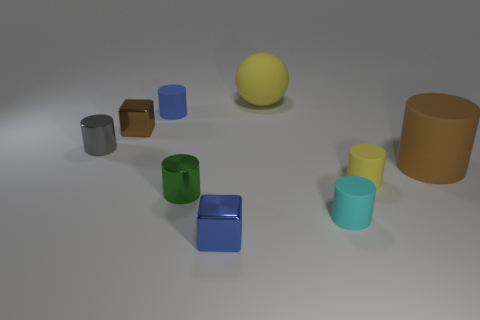Subtract all small yellow cylinders. How many cylinders are left? 5 Subtract all gray cylinders. How many cylinders are left? 5 Add 1 red metal things. How many objects exist? 10 Subtract all blocks. How many objects are left? 7 Subtract all yellow cylinders. Subtract all blue blocks. How many cylinders are left? 5 Subtract all shiny cylinders. Subtract all green things. How many objects are left? 6 Add 1 cyan matte cylinders. How many cyan matte cylinders are left? 2 Add 7 tiny yellow things. How many tiny yellow things exist? 8 Subtract 0 yellow cubes. How many objects are left? 9 